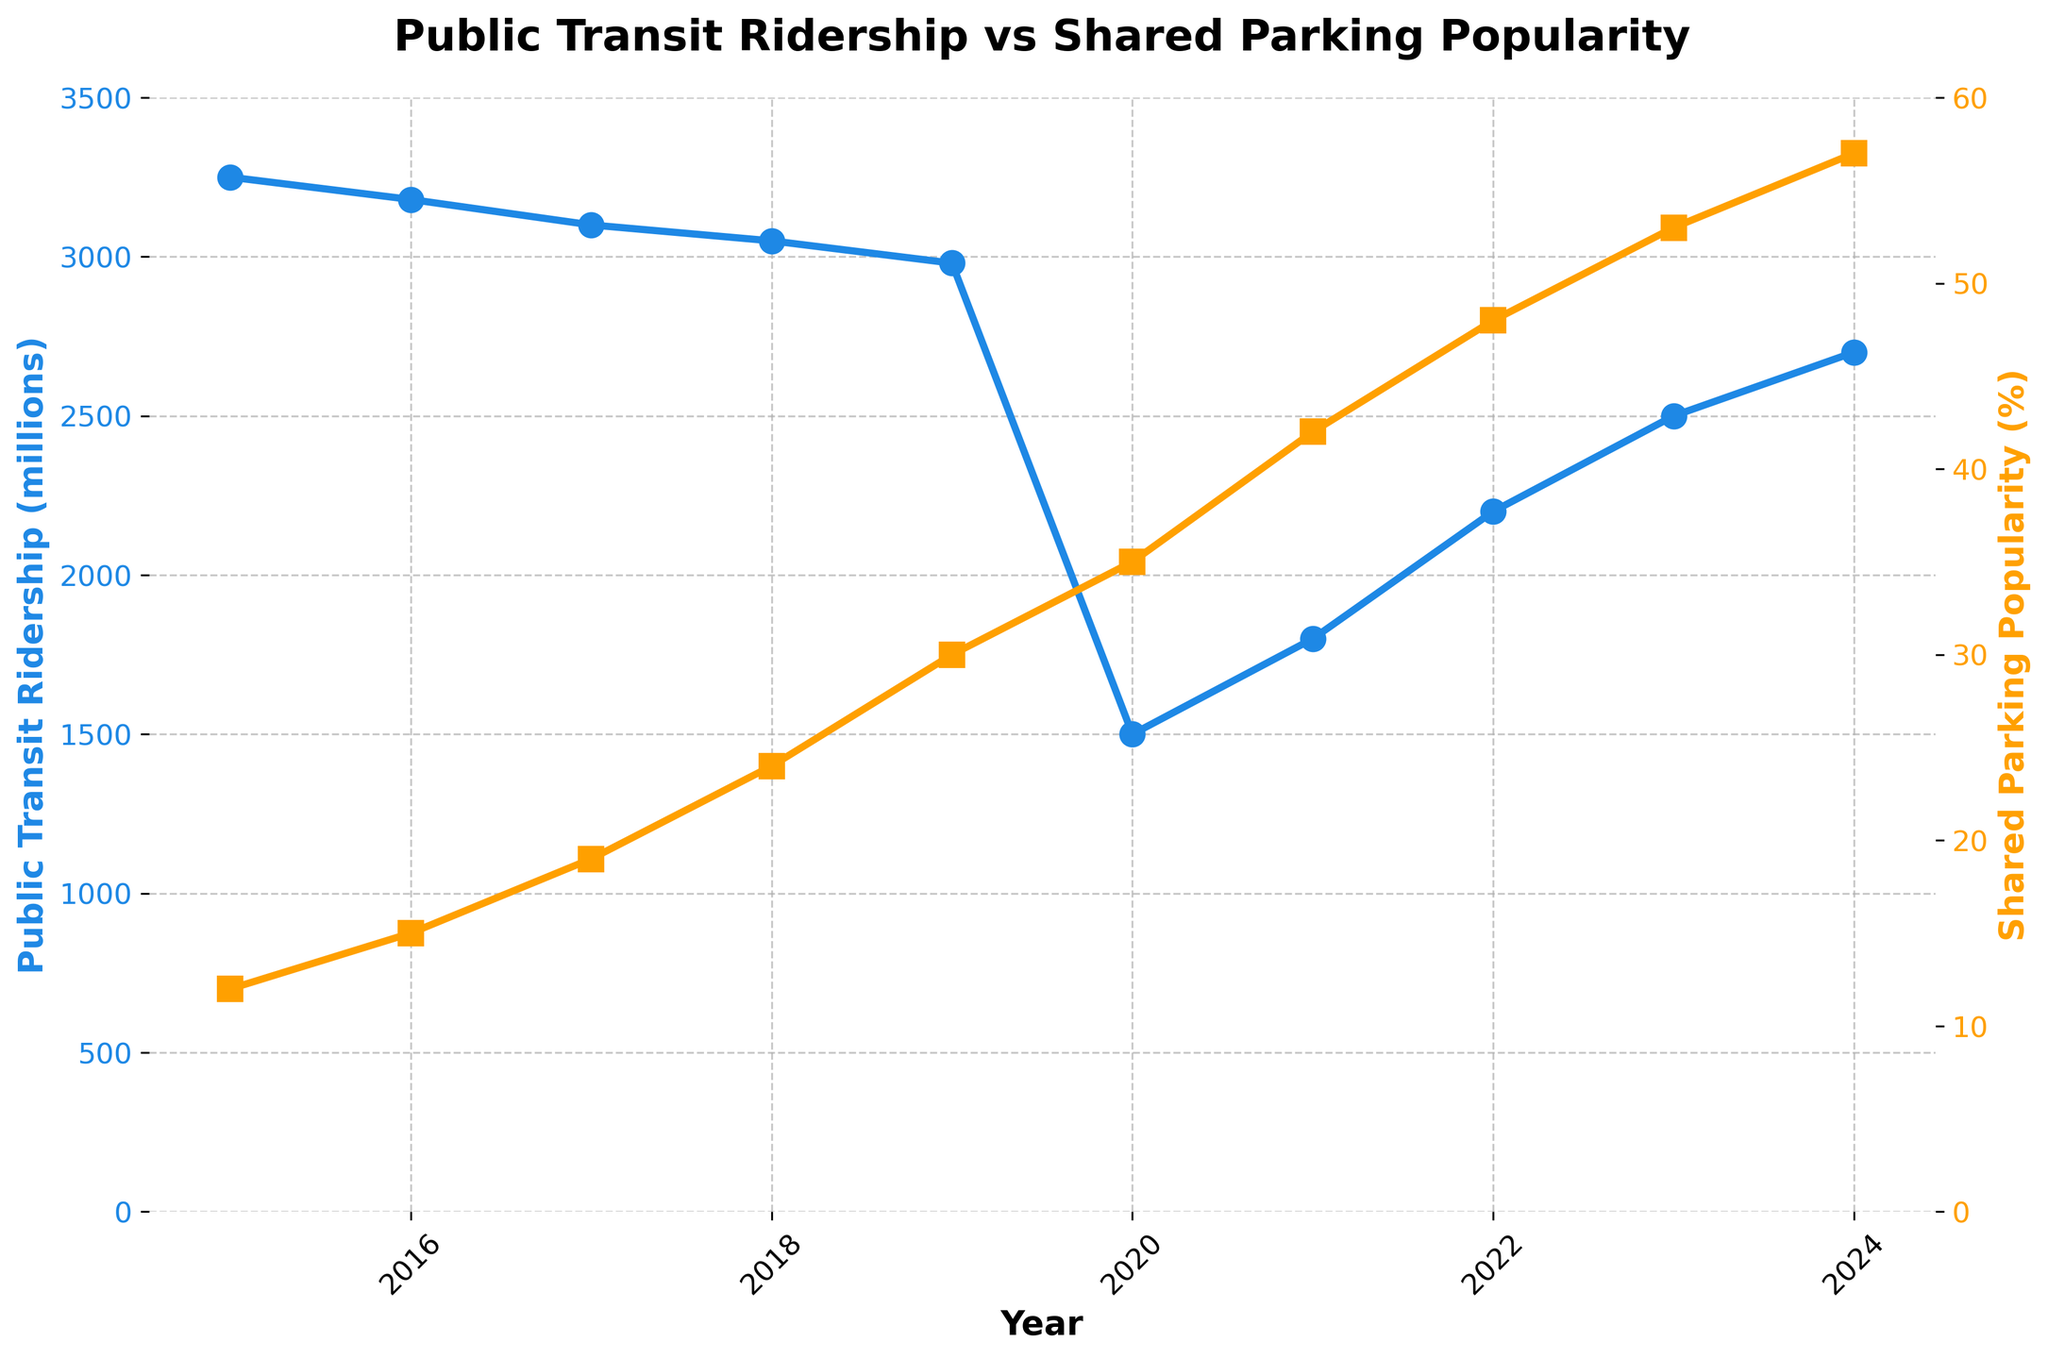What is the trend of public transit ridership from 2015 to 2024? By observing the blue line representing public transit ridership, we can see that it generally decreases from 2015 (3250 million) to 2020 (1500 million), showing a slight recovery afterwards, rising from 2021 to 2024.
Answer: Decreasing until 2020, then increasing What is the peak value of Shared Parking Popularity, and in which year does it occur? The orange line representing Shared Parking Popularity peaks at 57% in 2024.
Answer: 57%, 2024 Compare the shared parking popularity in 2016 and 2021. Which year had a higher popularity, and by how much? In 2016, the popularity was 15%, and in 2021, it was 42%. We calculate the difference by subtracting the 2016 value from the 2021 value. 42% - 15% = 27%.
Answer: 2021, 27% By how much did public transit ridership drop from 2019 to 2020? In 2019, the ridership was 2980 million, and in 2020, it was 1500 million. The drop is calculated as 2980 - 1500 = 1480 million.
Answer: 1480 million What's the average Shared Parking Popularity from 2015 to 2024? Add up the popularity percentages: 12 + 15 + 19 + 24 + 30 + 35 + 42 + 48 + 53 + 57 = 335. The average is then 335/10 = 33.5%.
Answer: 33.5% What visual trends can you notice about the colors of lines representing Public Transit Ridership and Shared Parking Popularity? The line representing Public Transit Ridership is colored blue, while the line representing Shared Parking Popularity is orange. The blue line generally slopes down before rising, whereas the orange line continuously slopes upwards.
Answer: Blue decreasing then increasing, orange increasing 